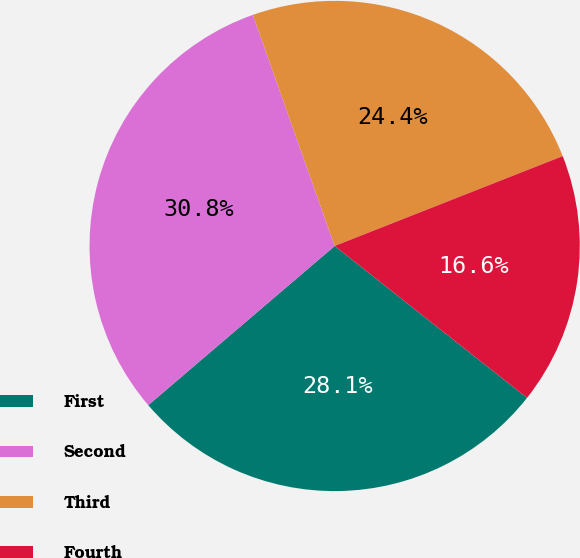<chart> <loc_0><loc_0><loc_500><loc_500><pie_chart><fcel>First<fcel>Second<fcel>Third<fcel>Fourth<nl><fcel>28.11%<fcel>30.83%<fcel>24.44%<fcel>16.61%<nl></chart> 